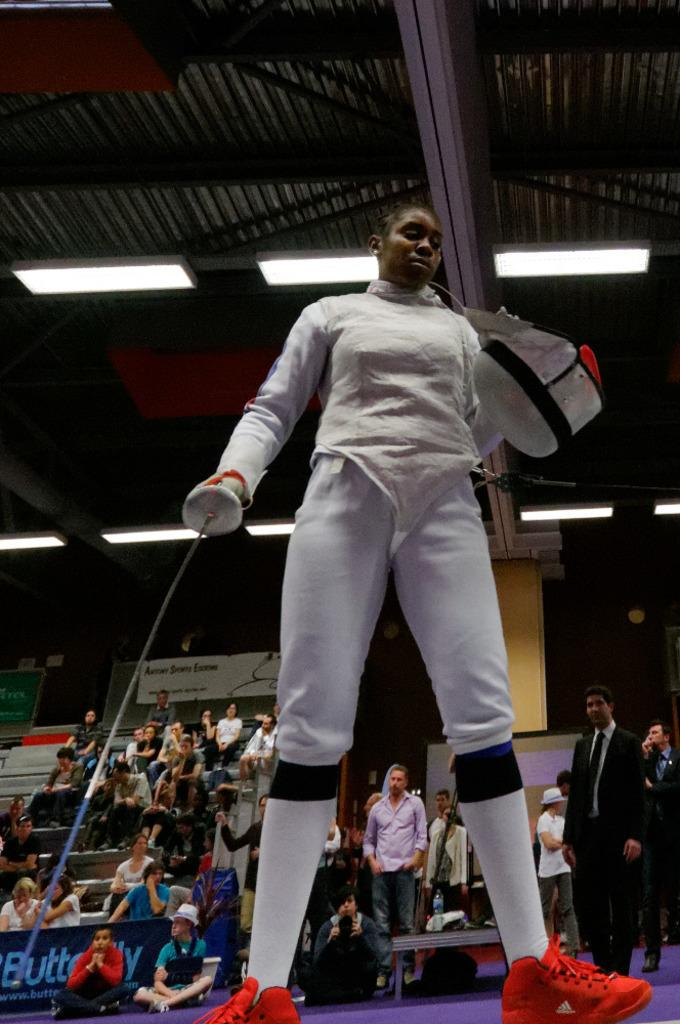What is the main subject of the image? The main subject of the image is a woman standing in the middle. What is the woman holding in her hands? The woman is holding a helmet and a knife. Can you describe the people behind the woman? There are people standing and sitting behind the woman. What can be seen at the top of the image? A roof and lights are visible at the top of the image. What type of leather is used to make the beds in the image? There are no beds present in the image, so it is not possible to determine the type of leather used for them. 